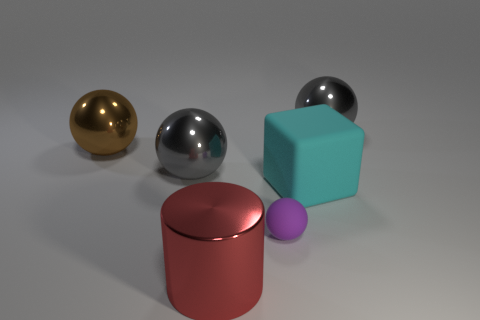Add 4 brown metal objects. How many objects exist? 10 Subtract all brown spheres. How many spheres are left? 3 Subtract all small purple spheres. How many spheres are left? 3 Subtract all red spheres. Subtract all green cylinders. How many spheres are left? 4 Subtract all cylinders. How many objects are left? 5 Subtract 0 green cubes. How many objects are left? 6 Subtract all matte spheres. Subtract all rubber objects. How many objects are left? 3 Add 6 tiny objects. How many tiny objects are left? 7 Add 1 large blue rubber objects. How many large blue rubber objects exist? 1 